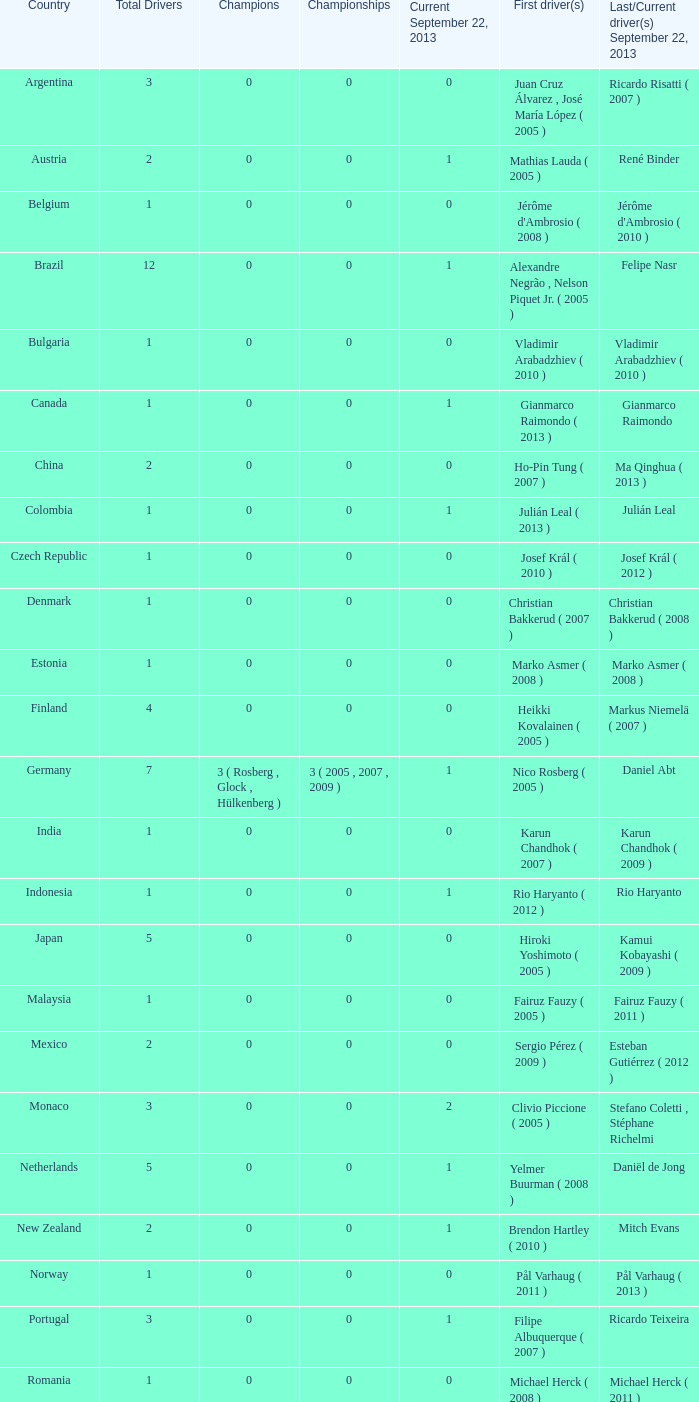How many champions were there when the most recent driver was gianmarco raimondo? 0.0. 